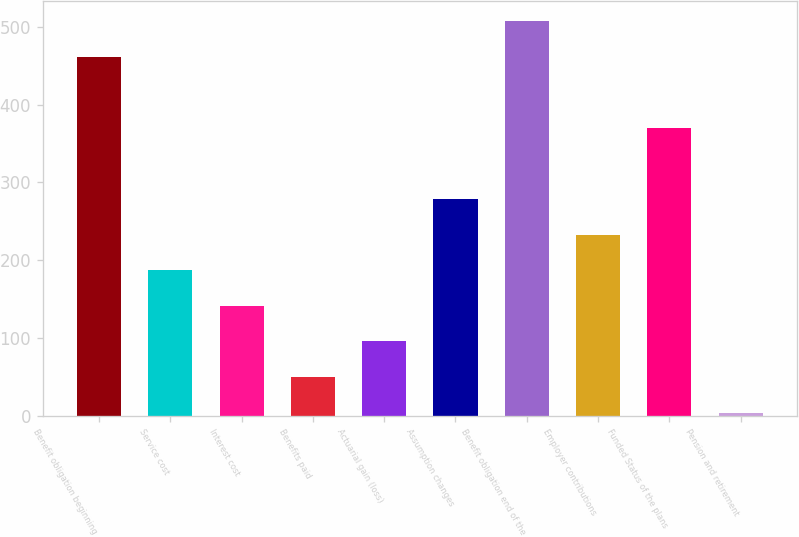<chart> <loc_0><loc_0><loc_500><loc_500><bar_chart><fcel>Benefit obligation beginning<fcel>Service cost<fcel>Interest cost<fcel>Benefits paid<fcel>Actuarial gain (loss)<fcel>Assumption changes<fcel>Benefit obligation end of the<fcel>Employer contributions<fcel>Funded Status of the plans<fcel>Pension and retirement<nl><fcel>461.8<fcel>187.3<fcel>141.55<fcel>50.05<fcel>95.8<fcel>278.8<fcel>507.55<fcel>233.05<fcel>370.3<fcel>4.3<nl></chart> 